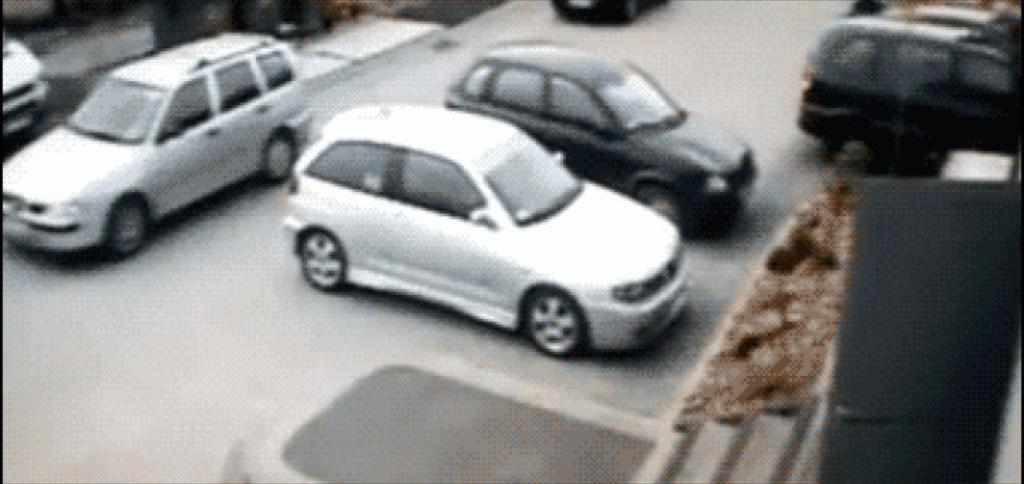What is happening on the road in the image? There are vehicles on the road in the image. Can you describe anything on the right side of the image? There is a board on the right side of the image. What type of seat can be seen on the board in the image? There is no seat present on the board in the image. What is the base of the board made of in the image? The base of the board is not visible or described in the image, so it cannot be determined. 